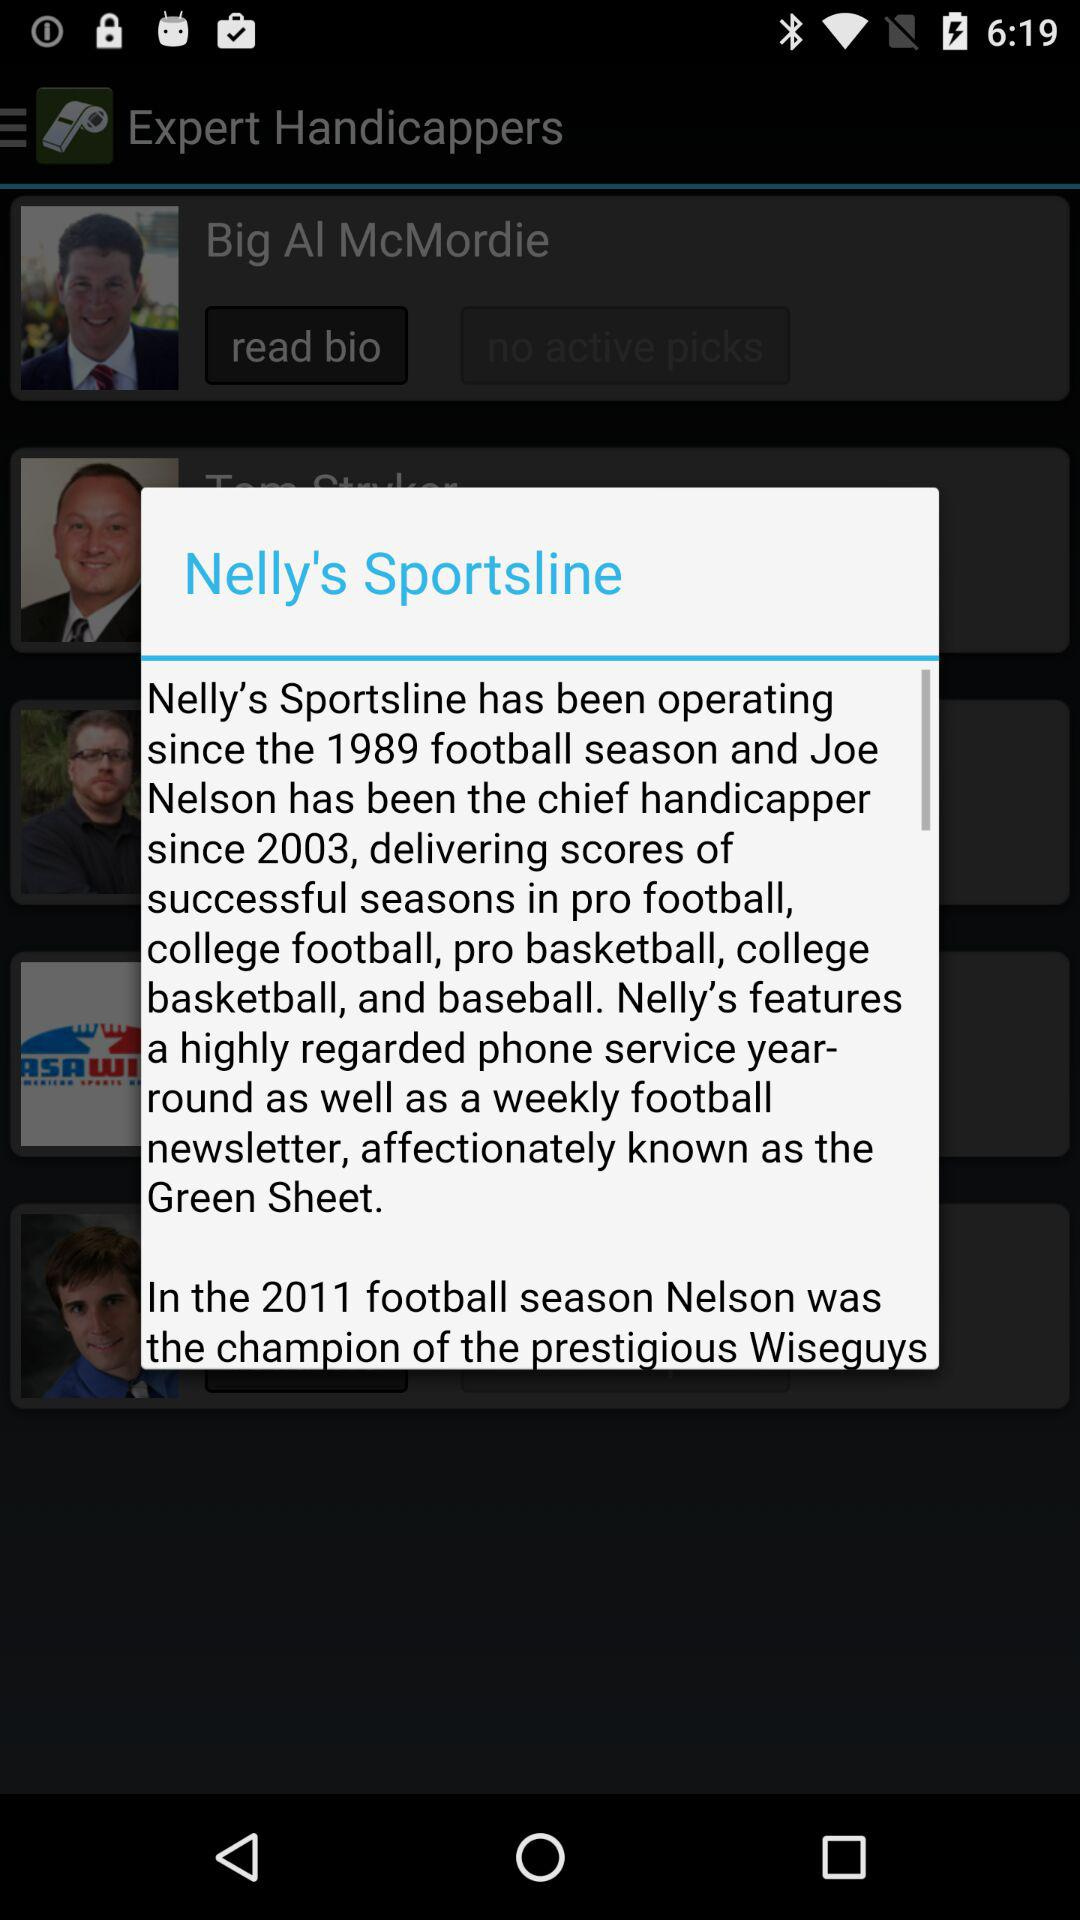How many years has Joe Nelson been the chief handicapper for Nelly's Sportsline?
Answer the question using a single word or phrase. 14 